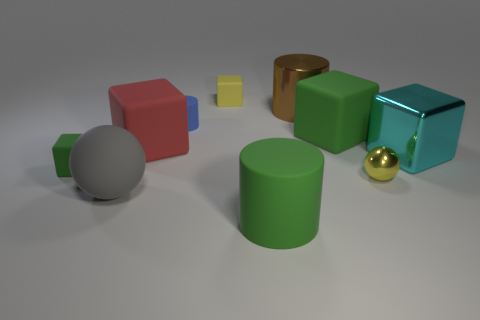Subtract all red cylinders. How many green blocks are left? 2 Subtract 2 cubes. How many cubes are left? 3 Subtract all red cubes. How many cubes are left? 4 Subtract all matte cubes. How many cubes are left? 1 Subtract all cylinders. How many objects are left? 7 Subtract all yellow blocks. Subtract all red cylinders. How many blocks are left? 4 Subtract all yellow metallic balls. Subtract all cyan blocks. How many objects are left? 8 Add 8 large red blocks. How many large red blocks are left? 9 Add 1 tiny blue cylinders. How many tiny blue cylinders exist? 2 Subtract 1 yellow spheres. How many objects are left? 9 